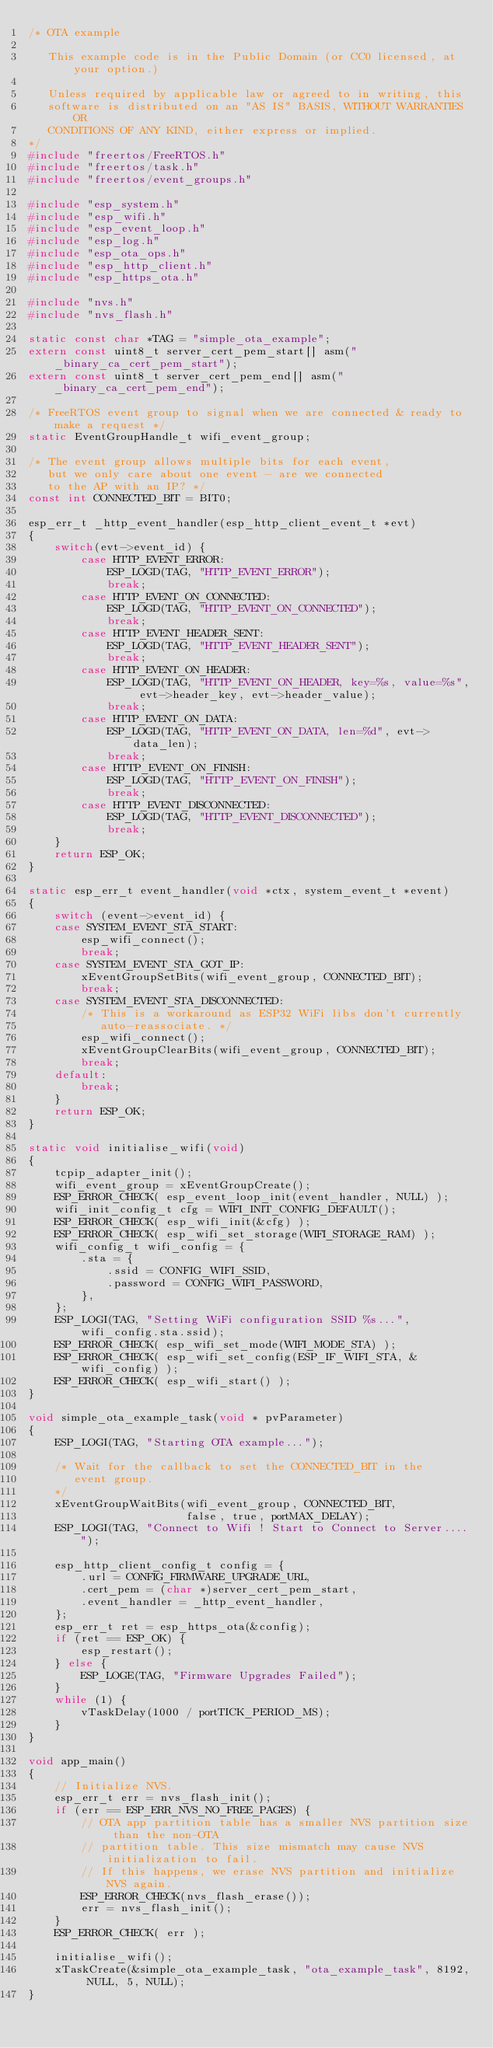<code> <loc_0><loc_0><loc_500><loc_500><_C_>/* OTA example

   This example code is in the Public Domain (or CC0 licensed, at your option.)

   Unless required by applicable law or agreed to in writing, this
   software is distributed on an "AS IS" BASIS, WITHOUT WARRANTIES OR
   CONDITIONS OF ANY KIND, either express or implied.
*/
#include "freertos/FreeRTOS.h"
#include "freertos/task.h"
#include "freertos/event_groups.h"

#include "esp_system.h"
#include "esp_wifi.h"
#include "esp_event_loop.h"
#include "esp_log.h"
#include "esp_ota_ops.h"
#include "esp_http_client.h"
#include "esp_https_ota.h"

#include "nvs.h"
#include "nvs_flash.h"

static const char *TAG = "simple_ota_example";
extern const uint8_t server_cert_pem_start[] asm("_binary_ca_cert_pem_start");
extern const uint8_t server_cert_pem_end[] asm("_binary_ca_cert_pem_end");

/* FreeRTOS event group to signal when we are connected & ready to make a request */
static EventGroupHandle_t wifi_event_group;

/* The event group allows multiple bits for each event,
   but we only care about one event - are we connected
   to the AP with an IP? */
const int CONNECTED_BIT = BIT0;

esp_err_t _http_event_handler(esp_http_client_event_t *evt)
{
    switch(evt->event_id) {
        case HTTP_EVENT_ERROR:
            ESP_LOGD(TAG, "HTTP_EVENT_ERROR");
            break;
        case HTTP_EVENT_ON_CONNECTED:
            ESP_LOGD(TAG, "HTTP_EVENT_ON_CONNECTED");
            break;
        case HTTP_EVENT_HEADER_SENT:
            ESP_LOGD(TAG, "HTTP_EVENT_HEADER_SENT");
            break;
        case HTTP_EVENT_ON_HEADER:
            ESP_LOGD(TAG, "HTTP_EVENT_ON_HEADER, key=%s, value=%s", evt->header_key, evt->header_value);
            break;
        case HTTP_EVENT_ON_DATA:
            ESP_LOGD(TAG, "HTTP_EVENT_ON_DATA, len=%d", evt->data_len);
            break;
        case HTTP_EVENT_ON_FINISH:
            ESP_LOGD(TAG, "HTTP_EVENT_ON_FINISH");
            break;
        case HTTP_EVENT_DISCONNECTED:
            ESP_LOGD(TAG, "HTTP_EVENT_DISCONNECTED");
            break;
    }
    return ESP_OK;
}

static esp_err_t event_handler(void *ctx, system_event_t *event)
{
    switch (event->event_id) {
    case SYSTEM_EVENT_STA_START:
        esp_wifi_connect();
        break;
    case SYSTEM_EVENT_STA_GOT_IP:
        xEventGroupSetBits(wifi_event_group, CONNECTED_BIT);
        break;
    case SYSTEM_EVENT_STA_DISCONNECTED:
        /* This is a workaround as ESP32 WiFi libs don't currently
           auto-reassociate. */
        esp_wifi_connect();
        xEventGroupClearBits(wifi_event_group, CONNECTED_BIT);
        break;
    default:
        break;
    }
    return ESP_OK;
}

static void initialise_wifi(void)
{
    tcpip_adapter_init();
    wifi_event_group = xEventGroupCreate();
    ESP_ERROR_CHECK( esp_event_loop_init(event_handler, NULL) );
    wifi_init_config_t cfg = WIFI_INIT_CONFIG_DEFAULT();
    ESP_ERROR_CHECK( esp_wifi_init(&cfg) );
    ESP_ERROR_CHECK( esp_wifi_set_storage(WIFI_STORAGE_RAM) );
    wifi_config_t wifi_config = {
        .sta = {
            .ssid = CONFIG_WIFI_SSID,
            .password = CONFIG_WIFI_PASSWORD,
        },
    };
    ESP_LOGI(TAG, "Setting WiFi configuration SSID %s...", wifi_config.sta.ssid);
    ESP_ERROR_CHECK( esp_wifi_set_mode(WIFI_MODE_STA) );
    ESP_ERROR_CHECK( esp_wifi_set_config(ESP_IF_WIFI_STA, &wifi_config) );
    ESP_ERROR_CHECK( esp_wifi_start() );
}

void simple_ota_example_task(void * pvParameter)
{
    ESP_LOGI(TAG, "Starting OTA example...");

    /* Wait for the callback to set the CONNECTED_BIT in the
       event group.
    */
    xEventGroupWaitBits(wifi_event_group, CONNECTED_BIT,
                        false, true, portMAX_DELAY);
    ESP_LOGI(TAG, "Connect to Wifi ! Start to Connect to Server....");
    
    esp_http_client_config_t config = {
        .url = CONFIG_FIRMWARE_UPGRADE_URL,
        .cert_pem = (char *)server_cert_pem_start,
        .event_handler = _http_event_handler,
    };
    esp_err_t ret = esp_https_ota(&config);
    if (ret == ESP_OK) {
        esp_restart();
    } else {
        ESP_LOGE(TAG, "Firmware Upgrades Failed");
    }
    while (1) {
        vTaskDelay(1000 / portTICK_PERIOD_MS);
    }
}

void app_main()
{
    // Initialize NVS.
    esp_err_t err = nvs_flash_init();
    if (err == ESP_ERR_NVS_NO_FREE_PAGES) {
        // OTA app partition table has a smaller NVS partition size than the non-OTA
        // partition table. This size mismatch may cause NVS initialization to fail.
        // If this happens, we erase NVS partition and initialize NVS again.
        ESP_ERROR_CHECK(nvs_flash_erase());
        err = nvs_flash_init();
    }
    ESP_ERROR_CHECK( err );

    initialise_wifi();
    xTaskCreate(&simple_ota_example_task, "ota_example_task", 8192, NULL, 5, NULL);
}
</code> 